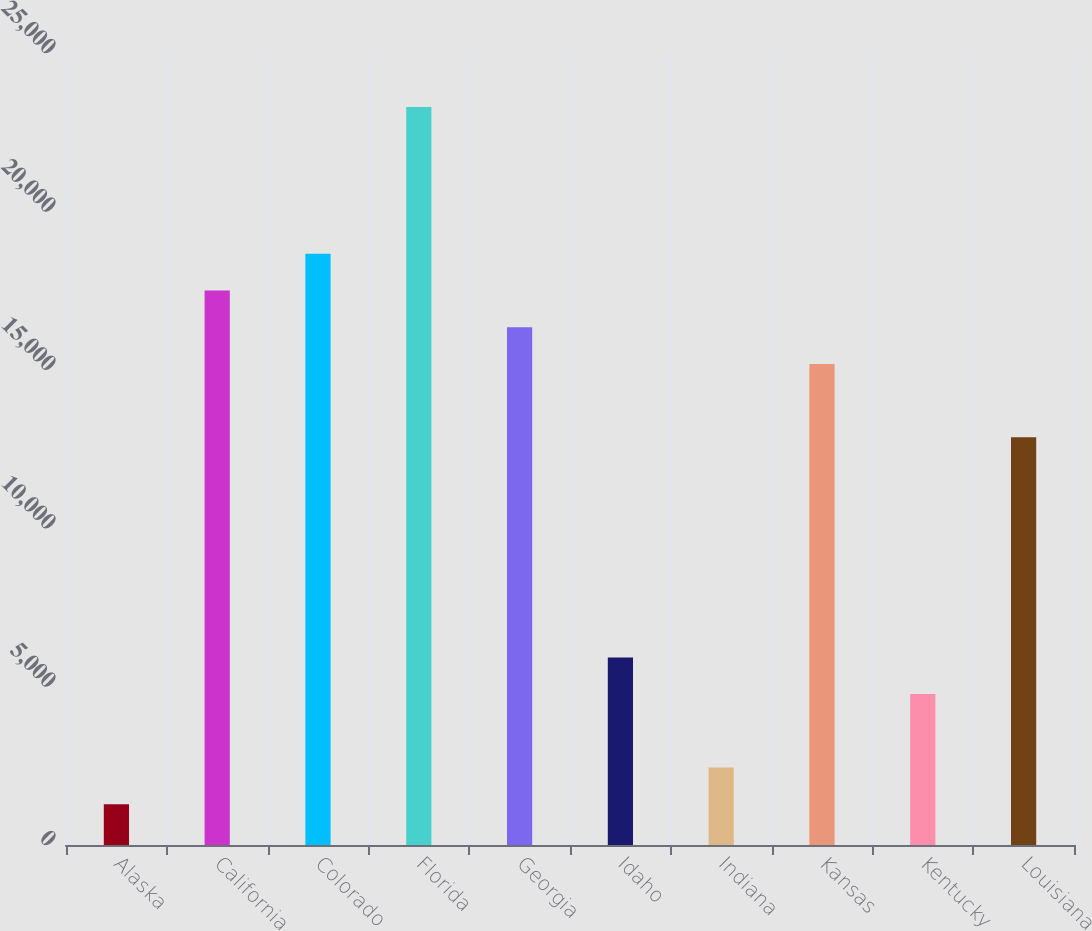Convert chart to OTSL. <chart><loc_0><loc_0><loc_500><loc_500><bar_chart><fcel>Alaska<fcel>California<fcel>Colorado<fcel>Florida<fcel>Georgia<fcel>Idaho<fcel>Indiana<fcel>Kansas<fcel>Kentucky<fcel>Louisiana<nl><fcel>1288.2<fcel>17503<fcel>18661.2<fcel>23294<fcel>16344.8<fcel>5921<fcel>2446.4<fcel>15186.6<fcel>4762.8<fcel>12870.2<nl></chart> 